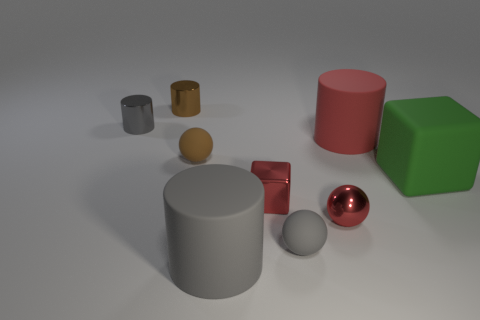Do the large red rubber object and the tiny brown thing that is behind the large red matte cylinder have the same shape? Yes, both the large red rubber object and the tiny brown object behind the red cylinder share a cylindrical shape. The red one is larger and has a matte surface,  while the brown one is smaller and appears to have a more reflective surface. 